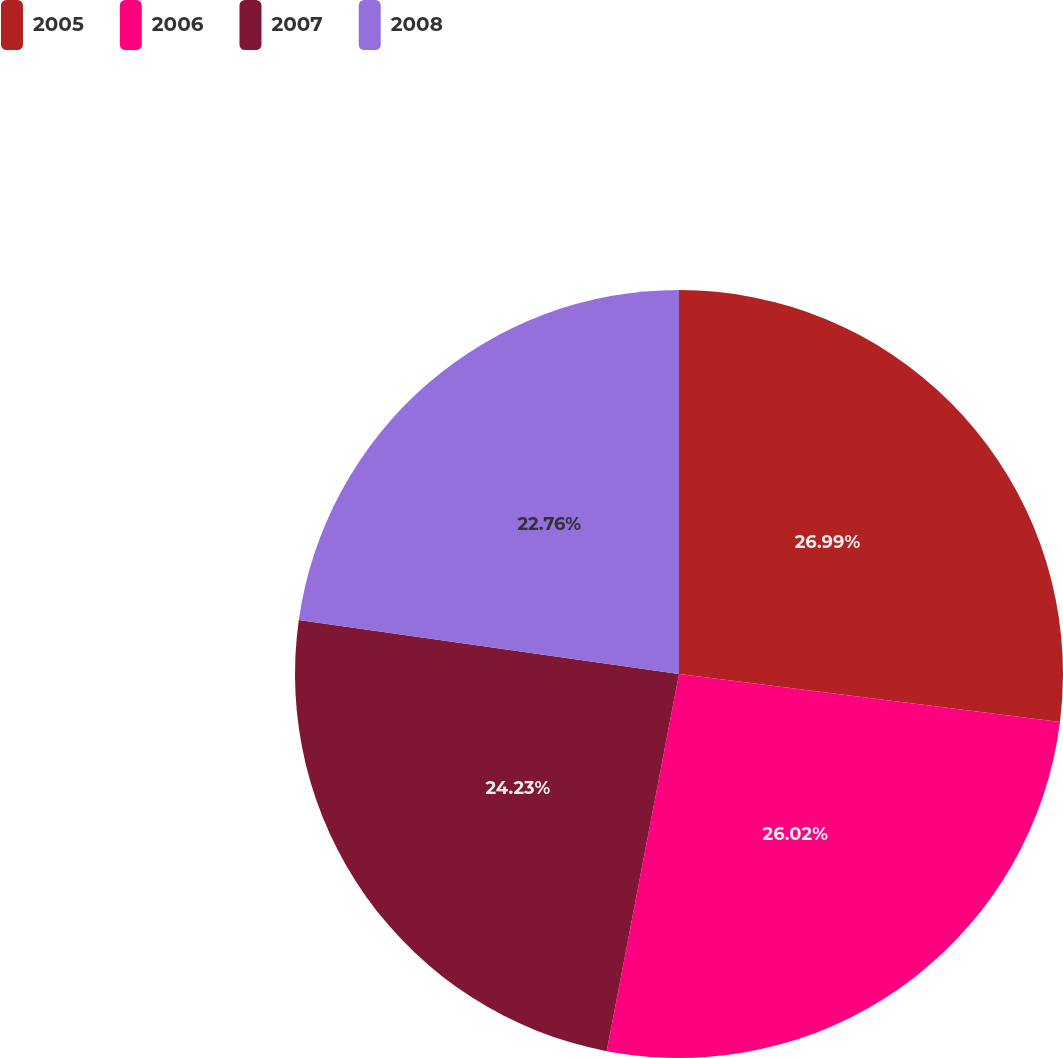Convert chart. <chart><loc_0><loc_0><loc_500><loc_500><pie_chart><fcel>2005<fcel>2006<fcel>2007<fcel>2008<nl><fcel>27.0%<fcel>26.02%<fcel>24.23%<fcel>22.76%<nl></chart> 